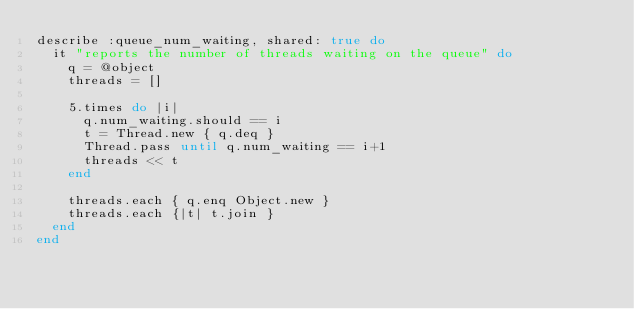<code> <loc_0><loc_0><loc_500><loc_500><_Ruby_>describe :queue_num_waiting, shared: true do
  it "reports the number of threads waiting on the queue" do
    q = @object
    threads = []

    5.times do |i|
      q.num_waiting.should == i
      t = Thread.new { q.deq }
      Thread.pass until q.num_waiting == i+1
      threads << t
    end

    threads.each { q.enq Object.new }
    threads.each {|t| t.join }
  end
end
</code> 